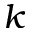<formula> <loc_0><loc_0><loc_500><loc_500>k</formula> 